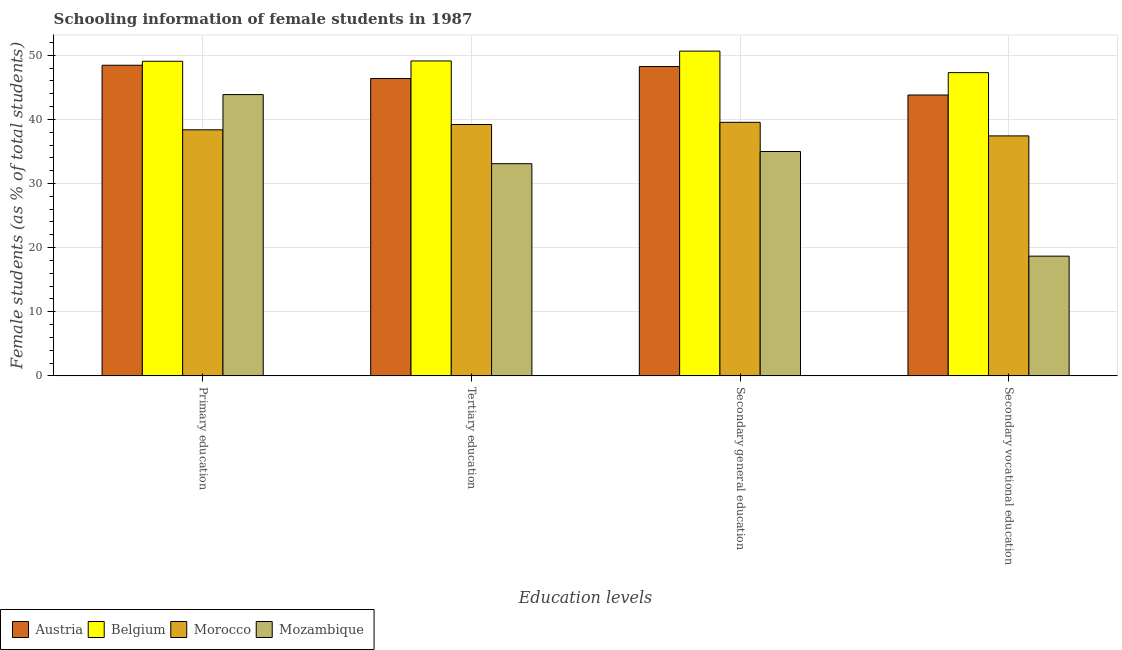How many groups of bars are there?
Your answer should be compact. 4. Are the number of bars per tick equal to the number of legend labels?
Keep it short and to the point. Yes. How many bars are there on the 3rd tick from the left?
Your response must be concise. 4. What is the label of the 2nd group of bars from the left?
Offer a terse response. Tertiary education. What is the percentage of female students in primary education in Belgium?
Your answer should be compact. 49.06. Across all countries, what is the maximum percentage of female students in tertiary education?
Make the answer very short. 49.11. Across all countries, what is the minimum percentage of female students in tertiary education?
Keep it short and to the point. 33.09. In which country was the percentage of female students in primary education maximum?
Make the answer very short. Belgium. In which country was the percentage of female students in primary education minimum?
Provide a short and direct response. Morocco. What is the total percentage of female students in tertiary education in the graph?
Make the answer very short. 167.75. What is the difference between the percentage of female students in secondary vocational education in Austria and that in Belgium?
Make the answer very short. -3.49. What is the difference between the percentage of female students in secondary vocational education in Belgium and the percentage of female students in secondary education in Mozambique?
Offer a terse response. 12.3. What is the average percentage of female students in tertiary education per country?
Your answer should be very brief. 41.94. What is the difference between the percentage of female students in tertiary education and percentage of female students in secondary vocational education in Belgium?
Your answer should be compact. 1.82. In how many countries, is the percentage of female students in primary education greater than 40 %?
Keep it short and to the point. 3. What is the ratio of the percentage of female students in secondary education in Morocco to that in Belgium?
Provide a succinct answer. 0.78. Is the percentage of female students in secondary education in Morocco less than that in Belgium?
Make the answer very short. Yes. What is the difference between the highest and the second highest percentage of female students in secondary vocational education?
Provide a succinct answer. 3.49. What is the difference between the highest and the lowest percentage of female students in primary education?
Offer a terse response. 10.69. What does the 4th bar from the left in Primary education represents?
Your answer should be very brief. Mozambique. What does the 1st bar from the right in Primary education represents?
Your response must be concise. Mozambique. Are all the bars in the graph horizontal?
Make the answer very short. No. How many countries are there in the graph?
Your answer should be very brief. 4. What is the difference between two consecutive major ticks on the Y-axis?
Ensure brevity in your answer.  10. Does the graph contain any zero values?
Offer a terse response. No. Where does the legend appear in the graph?
Your answer should be compact. Bottom left. What is the title of the graph?
Your response must be concise. Schooling information of female students in 1987. What is the label or title of the X-axis?
Provide a short and direct response. Education levels. What is the label or title of the Y-axis?
Make the answer very short. Female students (as % of total students). What is the Female students (as % of total students) of Austria in Primary education?
Provide a succinct answer. 48.44. What is the Female students (as % of total students) of Belgium in Primary education?
Make the answer very short. 49.06. What is the Female students (as % of total students) of Morocco in Primary education?
Offer a very short reply. 38.37. What is the Female students (as % of total students) of Mozambique in Primary education?
Ensure brevity in your answer.  43.86. What is the Female students (as % of total students) in Austria in Tertiary education?
Your answer should be compact. 46.36. What is the Female students (as % of total students) in Belgium in Tertiary education?
Offer a very short reply. 49.11. What is the Female students (as % of total students) of Morocco in Tertiary education?
Make the answer very short. 39.19. What is the Female students (as % of total students) of Mozambique in Tertiary education?
Provide a succinct answer. 33.09. What is the Female students (as % of total students) in Austria in Secondary general education?
Your answer should be very brief. 48.24. What is the Female students (as % of total students) of Belgium in Secondary general education?
Ensure brevity in your answer.  50.64. What is the Female students (as % of total students) in Morocco in Secondary general education?
Your response must be concise. 39.54. What is the Female students (as % of total students) of Mozambique in Secondary general education?
Provide a short and direct response. 34.99. What is the Female students (as % of total students) in Austria in Secondary vocational education?
Give a very brief answer. 43.8. What is the Female students (as % of total students) in Belgium in Secondary vocational education?
Give a very brief answer. 47.28. What is the Female students (as % of total students) in Morocco in Secondary vocational education?
Your answer should be very brief. 37.42. What is the Female students (as % of total students) of Mozambique in Secondary vocational education?
Your answer should be compact. 18.67. Across all Education levels, what is the maximum Female students (as % of total students) in Austria?
Give a very brief answer. 48.44. Across all Education levels, what is the maximum Female students (as % of total students) of Belgium?
Make the answer very short. 50.64. Across all Education levels, what is the maximum Female students (as % of total students) of Morocco?
Ensure brevity in your answer.  39.54. Across all Education levels, what is the maximum Female students (as % of total students) in Mozambique?
Provide a short and direct response. 43.86. Across all Education levels, what is the minimum Female students (as % of total students) of Austria?
Your response must be concise. 43.8. Across all Education levels, what is the minimum Female students (as % of total students) in Belgium?
Your answer should be compact. 47.28. Across all Education levels, what is the minimum Female students (as % of total students) of Morocco?
Make the answer very short. 37.42. Across all Education levels, what is the minimum Female students (as % of total students) in Mozambique?
Provide a succinct answer. 18.67. What is the total Female students (as % of total students) of Austria in the graph?
Give a very brief answer. 186.83. What is the total Female students (as % of total students) of Belgium in the graph?
Your answer should be very brief. 196.09. What is the total Female students (as % of total students) of Morocco in the graph?
Keep it short and to the point. 154.52. What is the total Female students (as % of total students) of Mozambique in the graph?
Your answer should be very brief. 130.61. What is the difference between the Female students (as % of total students) in Austria in Primary education and that in Tertiary education?
Give a very brief answer. 2.07. What is the difference between the Female students (as % of total students) of Belgium in Primary education and that in Tertiary education?
Provide a short and direct response. -0.05. What is the difference between the Female students (as % of total students) in Morocco in Primary education and that in Tertiary education?
Ensure brevity in your answer.  -0.82. What is the difference between the Female students (as % of total students) in Mozambique in Primary education and that in Tertiary education?
Your response must be concise. 10.77. What is the difference between the Female students (as % of total students) in Austria in Primary education and that in Secondary general education?
Provide a short and direct response. 0.2. What is the difference between the Female students (as % of total students) of Belgium in Primary education and that in Secondary general education?
Offer a terse response. -1.58. What is the difference between the Female students (as % of total students) of Morocco in Primary education and that in Secondary general education?
Offer a terse response. -1.17. What is the difference between the Female students (as % of total students) in Mozambique in Primary education and that in Secondary general education?
Your answer should be compact. 8.87. What is the difference between the Female students (as % of total students) of Austria in Primary education and that in Secondary vocational education?
Keep it short and to the point. 4.64. What is the difference between the Female students (as % of total students) in Belgium in Primary education and that in Secondary vocational education?
Provide a short and direct response. 1.77. What is the difference between the Female students (as % of total students) in Morocco in Primary education and that in Secondary vocational education?
Ensure brevity in your answer.  0.95. What is the difference between the Female students (as % of total students) in Mozambique in Primary education and that in Secondary vocational education?
Your answer should be very brief. 25.19. What is the difference between the Female students (as % of total students) in Austria in Tertiary education and that in Secondary general education?
Offer a terse response. -1.87. What is the difference between the Female students (as % of total students) in Belgium in Tertiary education and that in Secondary general education?
Provide a succinct answer. -1.53. What is the difference between the Female students (as % of total students) in Morocco in Tertiary education and that in Secondary general education?
Give a very brief answer. -0.34. What is the difference between the Female students (as % of total students) of Mozambique in Tertiary education and that in Secondary general education?
Offer a very short reply. -1.9. What is the difference between the Female students (as % of total students) in Austria in Tertiary education and that in Secondary vocational education?
Your answer should be compact. 2.57. What is the difference between the Female students (as % of total students) of Belgium in Tertiary education and that in Secondary vocational education?
Offer a terse response. 1.82. What is the difference between the Female students (as % of total students) of Morocco in Tertiary education and that in Secondary vocational education?
Keep it short and to the point. 1.77. What is the difference between the Female students (as % of total students) of Mozambique in Tertiary education and that in Secondary vocational education?
Provide a succinct answer. 14.42. What is the difference between the Female students (as % of total students) of Austria in Secondary general education and that in Secondary vocational education?
Your answer should be very brief. 4.44. What is the difference between the Female students (as % of total students) in Belgium in Secondary general education and that in Secondary vocational education?
Offer a very short reply. 3.36. What is the difference between the Female students (as % of total students) in Morocco in Secondary general education and that in Secondary vocational education?
Ensure brevity in your answer.  2.12. What is the difference between the Female students (as % of total students) in Mozambique in Secondary general education and that in Secondary vocational education?
Offer a terse response. 16.32. What is the difference between the Female students (as % of total students) of Austria in Primary education and the Female students (as % of total students) of Belgium in Tertiary education?
Your response must be concise. -0.67. What is the difference between the Female students (as % of total students) in Austria in Primary education and the Female students (as % of total students) in Morocco in Tertiary education?
Give a very brief answer. 9.24. What is the difference between the Female students (as % of total students) of Austria in Primary education and the Female students (as % of total students) of Mozambique in Tertiary education?
Keep it short and to the point. 15.35. What is the difference between the Female students (as % of total students) in Belgium in Primary education and the Female students (as % of total students) in Morocco in Tertiary education?
Your answer should be compact. 9.86. What is the difference between the Female students (as % of total students) of Belgium in Primary education and the Female students (as % of total students) of Mozambique in Tertiary education?
Provide a succinct answer. 15.97. What is the difference between the Female students (as % of total students) in Morocco in Primary education and the Female students (as % of total students) in Mozambique in Tertiary education?
Your answer should be very brief. 5.28. What is the difference between the Female students (as % of total students) in Austria in Primary education and the Female students (as % of total students) in Belgium in Secondary general education?
Ensure brevity in your answer.  -2.2. What is the difference between the Female students (as % of total students) in Austria in Primary education and the Female students (as % of total students) in Morocco in Secondary general education?
Offer a very short reply. 8.9. What is the difference between the Female students (as % of total students) in Austria in Primary education and the Female students (as % of total students) in Mozambique in Secondary general education?
Ensure brevity in your answer.  13.45. What is the difference between the Female students (as % of total students) of Belgium in Primary education and the Female students (as % of total students) of Morocco in Secondary general education?
Your answer should be very brief. 9.52. What is the difference between the Female students (as % of total students) in Belgium in Primary education and the Female students (as % of total students) in Mozambique in Secondary general education?
Your response must be concise. 14.07. What is the difference between the Female students (as % of total students) of Morocco in Primary education and the Female students (as % of total students) of Mozambique in Secondary general education?
Offer a very short reply. 3.38. What is the difference between the Female students (as % of total students) in Austria in Primary education and the Female students (as % of total students) in Belgium in Secondary vocational education?
Provide a short and direct response. 1.15. What is the difference between the Female students (as % of total students) in Austria in Primary education and the Female students (as % of total students) in Morocco in Secondary vocational education?
Your answer should be compact. 11.02. What is the difference between the Female students (as % of total students) of Austria in Primary education and the Female students (as % of total students) of Mozambique in Secondary vocational education?
Your answer should be compact. 29.77. What is the difference between the Female students (as % of total students) of Belgium in Primary education and the Female students (as % of total students) of Morocco in Secondary vocational education?
Give a very brief answer. 11.64. What is the difference between the Female students (as % of total students) in Belgium in Primary education and the Female students (as % of total students) in Mozambique in Secondary vocational education?
Your answer should be very brief. 30.39. What is the difference between the Female students (as % of total students) in Morocco in Primary education and the Female students (as % of total students) in Mozambique in Secondary vocational education?
Give a very brief answer. 19.7. What is the difference between the Female students (as % of total students) in Austria in Tertiary education and the Female students (as % of total students) in Belgium in Secondary general education?
Give a very brief answer. -4.28. What is the difference between the Female students (as % of total students) of Austria in Tertiary education and the Female students (as % of total students) of Morocco in Secondary general education?
Keep it short and to the point. 6.83. What is the difference between the Female students (as % of total students) in Austria in Tertiary education and the Female students (as % of total students) in Mozambique in Secondary general education?
Offer a very short reply. 11.38. What is the difference between the Female students (as % of total students) in Belgium in Tertiary education and the Female students (as % of total students) in Morocco in Secondary general education?
Give a very brief answer. 9.57. What is the difference between the Female students (as % of total students) of Belgium in Tertiary education and the Female students (as % of total students) of Mozambique in Secondary general education?
Offer a very short reply. 14.12. What is the difference between the Female students (as % of total students) of Morocco in Tertiary education and the Female students (as % of total students) of Mozambique in Secondary general education?
Offer a very short reply. 4.21. What is the difference between the Female students (as % of total students) in Austria in Tertiary education and the Female students (as % of total students) in Belgium in Secondary vocational education?
Ensure brevity in your answer.  -0.92. What is the difference between the Female students (as % of total students) of Austria in Tertiary education and the Female students (as % of total students) of Morocco in Secondary vocational education?
Offer a terse response. 8.94. What is the difference between the Female students (as % of total students) in Austria in Tertiary education and the Female students (as % of total students) in Mozambique in Secondary vocational education?
Your response must be concise. 27.7. What is the difference between the Female students (as % of total students) of Belgium in Tertiary education and the Female students (as % of total students) of Morocco in Secondary vocational education?
Your answer should be very brief. 11.69. What is the difference between the Female students (as % of total students) of Belgium in Tertiary education and the Female students (as % of total students) of Mozambique in Secondary vocational education?
Provide a short and direct response. 30.44. What is the difference between the Female students (as % of total students) in Morocco in Tertiary education and the Female students (as % of total students) in Mozambique in Secondary vocational education?
Ensure brevity in your answer.  20.53. What is the difference between the Female students (as % of total students) of Austria in Secondary general education and the Female students (as % of total students) of Belgium in Secondary vocational education?
Make the answer very short. 0.95. What is the difference between the Female students (as % of total students) in Austria in Secondary general education and the Female students (as % of total students) in Morocco in Secondary vocational education?
Offer a very short reply. 10.82. What is the difference between the Female students (as % of total students) in Austria in Secondary general education and the Female students (as % of total students) in Mozambique in Secondary vocational education?
Provide a short and direct response. 29.57. What is the difference between the Female students (as % of total students) of Belgium in Secondary general education and the Female students (as % of total students) of Morocco in Secondary vocational education?
Your response must be concise. 13.22. What is the difference between the Female students (as % of total students) in Belgium in Secondary general education and the Female students (as % of total students) in Mozambique in Secondary vocational education?
Keep it short and to the point. 31.97. What is the difference between the Female students (as % of total students) of Morocco in Secondary general education and the Female students (as % of total students) of Mozambique in Secondary vocational education?
Keep it short and to the point. 20.87. What is the average Female students (as % of total students) in Austria per Education levels?
Offer a terse response. 46.71. What is the average Female students (as % of total students) of Belgium per Education levels?
Make the answer very short. 49.02. What is the average Female students (as % of total students) of Morocco per Education levels?
Make the answer very short. 38.63. What is the average Female students (as % of total students) in Mozambique per Education levels?
Ensure brevity in your answer.  32.65. What is the difference between the Female students (as % of total students) of Austria and Female students (as % of total students) of Belgium in Primary education?
Provide a succinct answer. -0.62. What is the difference between the Female students (as % of total students) of Austria and Female students (as % of total students) of Morocco in Primary education?
Provide a succinct answer. 10.07. What is the difference between the Female students (as % of total students) in Austria and Female students (as % of total students) in Mozambique in Primary education?
Your answer should be compact. 4.58. What is the difference between the Female students (as % of total students) in Belgium and Female students (as % of total students) in Morocco in Primary education?
Offer a very short reply. 10.69. What is the difference between the Female students (as % of total students) of Belgium and Female students (as % of total students) of Mozambique in Primary education?
Ensure brevity in your answer.  5.2. What is the difference between the Female students (as % of total students) in Morocco and Female students (as % of total students) in Mozambique in Primary education?
Offer a very short reply. -5.49. What is the difference between the Female students (as % of total students) of Austria and Female students (as % of total students) of Belgium in Tertiary education?
Make the answer very short. -2.75. What is the difference between the Female students (as % of total students) in Austria and Female students (as % of total students) in Morocco in Tertiary education?
Keep it short and to the point. 7.17. What is the difference between the Female students (as % of total students) of Austria and Female students (as % of total students) of Mozambique in Tertiary education?
Provide a short and direct response. 13.27. What is the difference between the Female students (as % of total students) in Belgium and Female students (as % of total students) in Morocco in Tertiary education?
Give a very brief answer. 9.91. What is the difference between the Female students (as % of total students) in Belgium and Female students (as % of total students) in Mozambique in Tertiary education?
Your response must be concise. 16.02. What is the difference between the Female students (as % of total students) in Morocco and Female students (as % of total students) in Mozambique in Tertiary education?
Your response must be concise. 6.11. What is the difference between the Female students (as % of total students) of Austria and Female students (as % of total students) of Belgium in Secondary general education?
Your answer should be very brief. -2.4. What is the difference between the Female students (as % of total students) of Austria and Female students (as % of total students) of Morocco in Secondary general education?
Provide a short and direct response. 8.7. What is the difference between the Female students (as % of total students) of Austria and Female students (as % of total students) of Mozambique in Secondary general education?
Your answer should be very brief. 13.25. What is the difference between the Female students (as % of total students) in Belgium and Female students (as % of total students) in Morocco in Secondary general education?
Your answer should be very brief. 11.1. What is the difference between the Female students (as % of total students) in Belgium and Female students (as % of total students) in Mozambique in Secondary general education?
Offer a very short reply. 15.65. What is the difference between the Female students (as % of total students) of Morocco and Female students (as % of total students) of Mozambique in Secondary general education?
Make the answer very short. 4.55. What is the difference between the Female students (as % of total students) in Austria and Female students (as % of total students) in Belgium in Secondary vocational education?
Your answer should be compact. -3.49. What is the difference between the Female students (as % of total students) of Austria and Female students (as % of total students) of Morocco in Secondary vocational education?
Your answer should be very brief. 6.38. What is the difference between the Female students (as % of total students) in Austria and Female students (as % of total students) in Mozambique in Secondary vocational education?
Ensure brevity in your answer.  25.13. What is the difference between the Female students (as % of total students) in Belgium and Female students (as % of total students) in Morocco in Secondary vocational education?
Your answer should be very brief. 9.87. What is the difference between the Female students (as % of total students) of Belgium and Female students (as % of total students) of Mozambique in Secondary vocational education?
Your response must be concise. 28.62. What is the difference between the Female students (as % of total students) in Morocco and Female students (as % of total students) in Mozambique in Secondary vocational education?
Provide a short and direct response. 18.75. What is the ratio of the Female students (as % of total students) of Austria in Primary education to that in Tertiary education?
Make the answer very short. 1.04. What is the ratio of the Female students (as % of total students) of Morocco in Primary education to that in Tertiary education?
Offer a very short reply. 0.98. What is the ratio of the Female students (as % of total students) of Mozambique in Primary education to that in Tertiary education?
Your answer should be very brief. 1.33. What is the ratio of the Female students (as % of total students) in Austria in Primary education to that in Secondary general education?
Your answer should be very brief. 1. What is the ratio of the Female students (as % of total students) of Belgium in Primary education to that in Secondary general education?
Offer a terse response. 0.97. What is the ratio of the Female students (as % of total students) in Morocco in Primary education to that in Secondary general education?
Offer a terse response. 0.97. What is the ratio of the Female students (as % of total students) in Mozambique in Primary education to that in Secondary general education?
Give a very brief answer. 1.25. What is the ratio of the Female students (as % of total students) in Austria in Primary education to that in Secondary vocational education?
Provide a succinct answer. 1.11. What is the ratio of the Female students (as % of total students) in Belgium in Primary education to that in Secondary vocational education?
Your response must be concise. 1.04. What is the ratio of the Female students (as % of total students) of Morocco in Primary education to that in Secondary vocational education?
Make the answer very short. 1.03. What is the ratio of the Female students (as % of total students) of Mozambique in Primary education to that in Secondary vocational education?
Your answer should be compact. 2.35. What is the ratio of the Female students (as % of total students) of Austria in Tertiary education to that in Secondary general education?
Give a very brief answer. 0.96. What is the ratio of the Female students (as % of total students) in Belgium in Tertiary education to that in Secondary general education?
Your response must be concise. 0.97. What is the ratio of the Female students (as % of total students) of Morocco in Tertiary education to that in Secondary general education?
Give a very brief answer. 0.99. What is the ratio of the Female students (as % of total students) of Mozambique in Tertiary education to that in Secondary general education?
Provide a succinct answer. 0.95. What is the ratio of the Female students (as % of total students) of Austria in Tertiary education to that in Secondary vocational education?
Give a very brief answer. 1.06. What is the ratio of the Female students (as % of total students) of Belgium in Tertiary education to that in Secondary vocational education?
Your answer should be compact. 1.04. What is the ratio of the Female students (as % of total students) in Morocco in Tertiary education to that in Secondary vocational education?
Your answer should be compact. 1.05. What is the ratio of the Female students (as % of total students) in Mozambique in Tertiary education to that in Secondary vocational education?
Provide a short and direct response. 1.77. What is the ratio of the Female students (as % of total students) in Austria in Secondary general education to that in Secondary vocational education?
Provide a succinct answer. 1.1. What is the ratio of the Female students (as % of total students) of Belgium in Secondary general education to that in Secondary vocational education?
Your response must be concise. 1.07. What is the ratio of the Female students (as % of total students) in Morocco in Secondary general education to that in Secondary vocational education?
Ensure brevity in your answer.  1.06. What is the ratio of the Female students (as % of total students) of Mozambique in Secondary general education to that in Secondary vocational education?
Make the answer very short. 1.87. What is the difference between the highest and the second highest Female students (as % of total students) in Austria?
Offer a terse response. 0.2. What is the difference between the highest and the second highest Female students (as % of total students) in Belgium?
Give a very brief answer. 1.53. What is the difference between the highest and the second highest Female students (as % of total students) in Morocco?
Provide a short and direct response. 0.34. What is the difference between the highest and the second highest Female students (as % of total students) in Mozambique?
Your answer should be very brief. 8.87. What is the difference between the highest and the lowest Female students (as % of total students) in Austria?
Give a very brief answer. 4.64. What is the difference between the highest and the lowest Female students (as % of total students) of Belgium?
Give a very brief answer. 3.36. What is the difference between the highest and the lowest Female students (as % of total students) of Morocco?
Provide a succinct answer. 2.12. What is the difference between the highest and the lowest Female students (as % of total students) of Mozambique?
Your response must be concise. 25.19. 